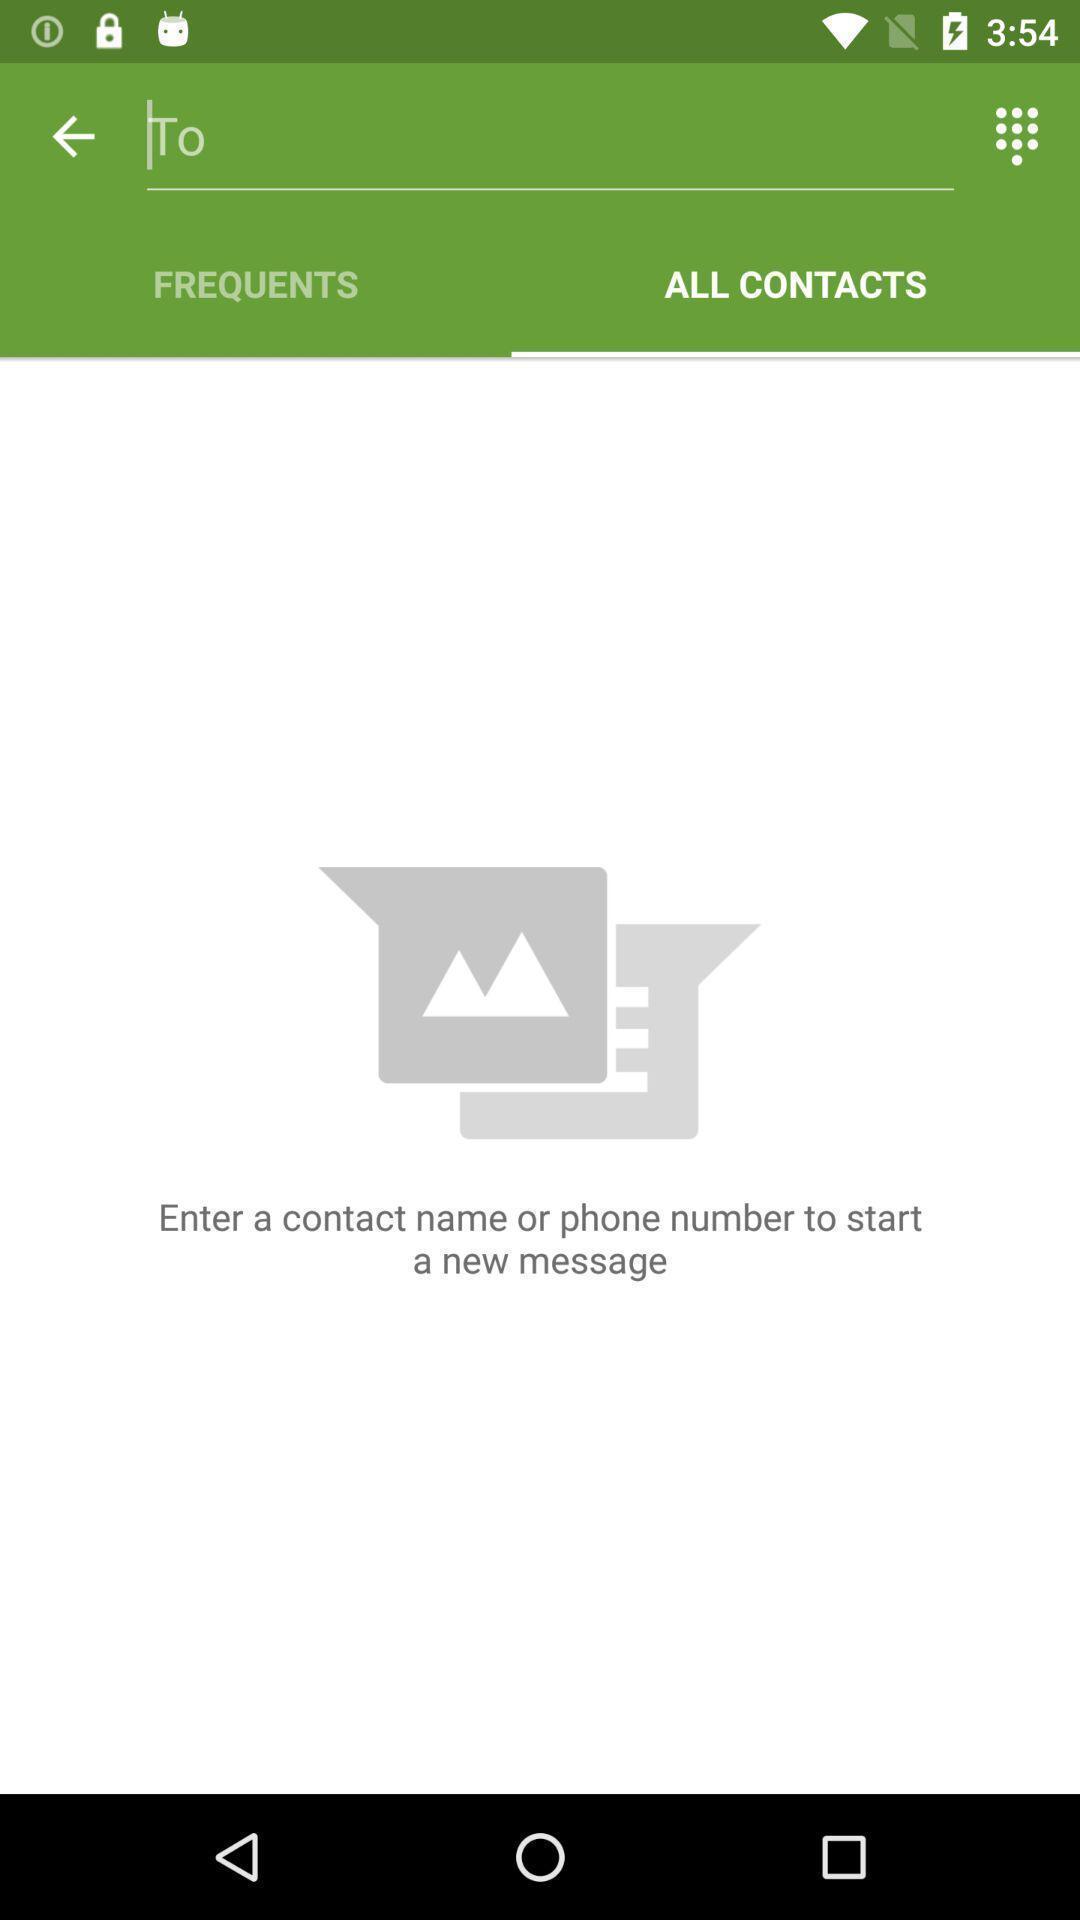Provide a textual representation of this image. Search box displaying in this page. 